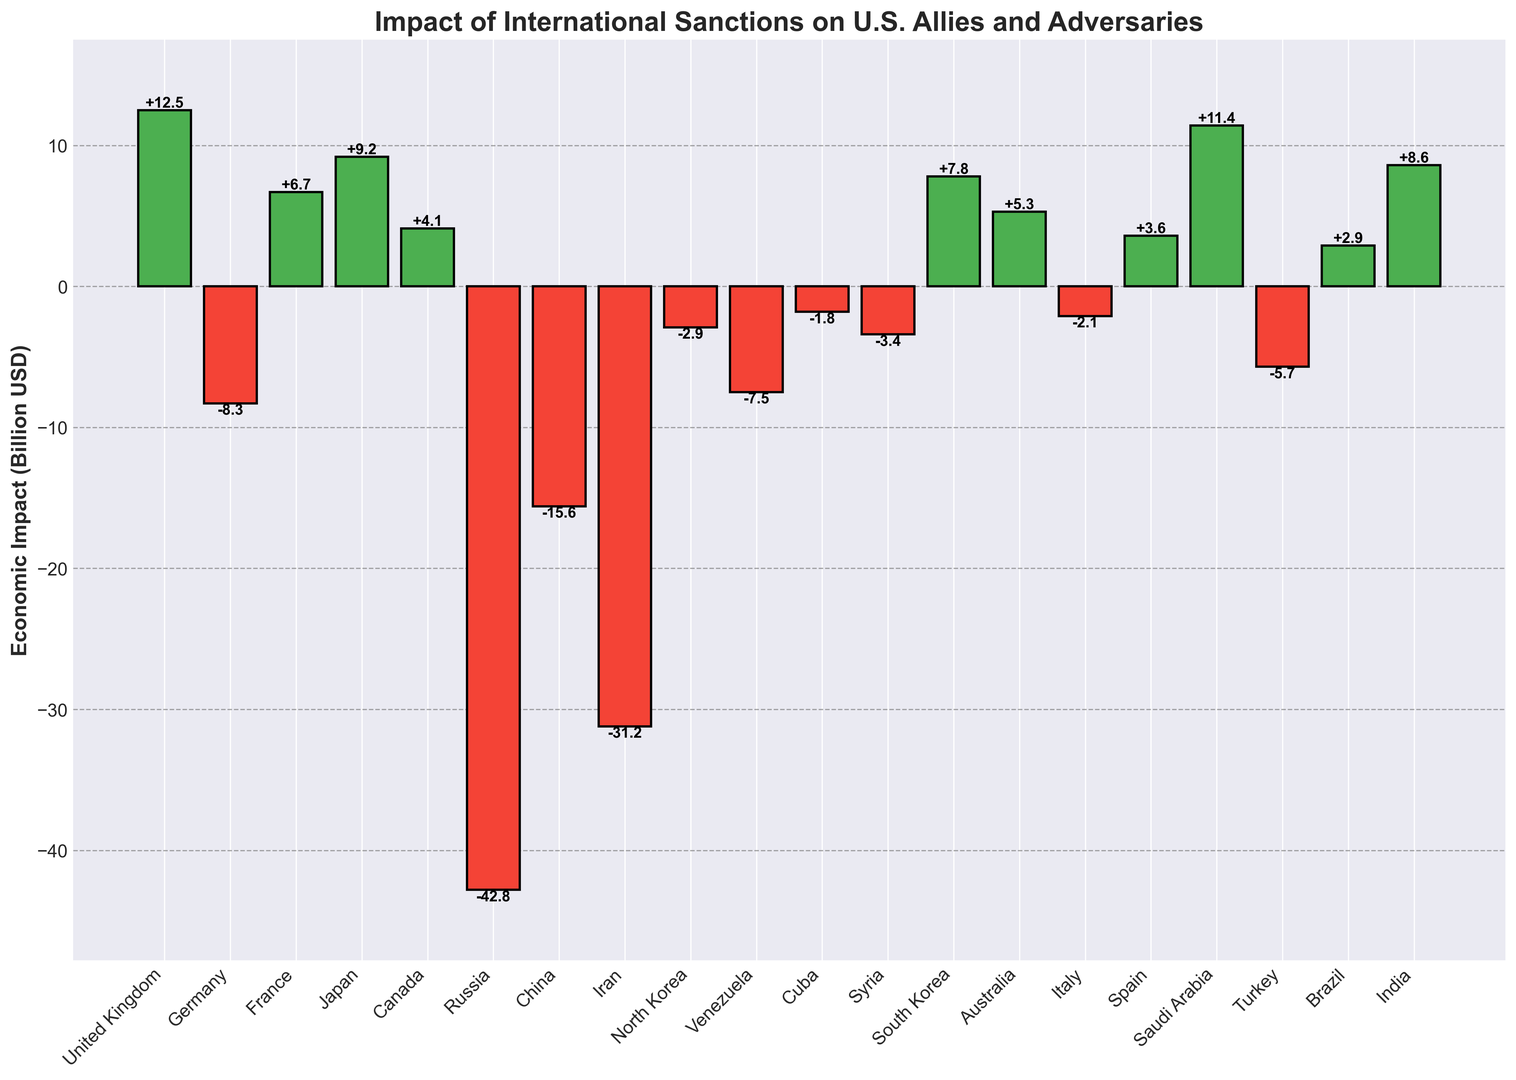Which country experiences the largest economic loss due to international sanctions? By observing the bars, the bar representing Russia has the greatest negative height.
Answer: Russia Which countries have gained economically from international sanctions? Bars that are green indicate economic gain. The countries with green bars are the United Kingdom, France, Japan, Canada, South Korea, Australia, Spain, Saudi Arabia, Brazil, and India.
Answer: United Kingdom, France, Japan, Canada, South Korea, Australia, Spain, Saudi Arabia, Brazil, India What is the total economic impact for U.S. allies? (consider United Kingdom, Germany, France, Japan, Canada, South Korea, Australia, Italy, Spain, Saudi Arabia, Turkey) Sum the economic impacts of each of these countries: 12.5 - 8.3 + 6.7 + 9.2 + 4.1 + 7.8 + 5.3 - 2.1 + 3.6 + 11.4 - 5.7 = 44.5 billion USD.
Answer: 44.5 billion USD What is the average economic gain for all countries that have a positive impact? Sum the gains (+12.5, +6.7, +9.2, +4.1, +7.8, +5.3, +3.6, +11.4, +2.9, +8.6), which equals 72.1 billion USD, divided by the number of countries (10). The average gain is 72.1/10 = 7.21 billion USD.
Answer: 7.21 billion USD Compare the economic impact of Japan and China. Japan has a positive impact of +9.2 billion USD while China has a negative impact of -15.6 billion USD. Thus, Japan's economic gain (+9.2) is greater than China's economic loss (-15.6).
Answer: Japan has a greater economic impact Which countries have a negative economic impact that is less (in absolute terms) than -5 billion USD? Bars with negative values less than -5, in absolute terms, include countries like Germany (-8.3), Turkey (-5.7), Iran (-31.2), Venezuela (-7.5), China (-15.6), and Russia (-42.8).
Answer: Germany, Turkey, Iran, Venezuela, China, Russia What is the combined economic impact for the countries in the Middle East (consider Syria, Saudi Arabia, and Iran)? Sum the economic impacts of these countries: -3.4 + 11.4 - 31.2 = -23.2 billion USD.
Answer: -23.2 billion USD Which country has an economic gain that is closest to 5 billion USD? Australia has an economic gain of 5.3 billion USD, which is closest to 5 billion USD.
Answer: Australia What is the net economic impact for the adversaries of the U.S. (consider Russia, China, Iran, North Korea, Venezuela, Cuba, Syria)? Sum the economic impacts: -42.8 -15.6 -31.2 -2.9 -7.5 -1.8 -3.4 = -105.2 billion USD.
Answer: -105.2 billion USD Which countries have bars of equal height but opposite in color, i.e., green and red bars with the same economic impact value? By observing the bars, none of the countries have green and red bars with the same economic impact value.
Answer: None 